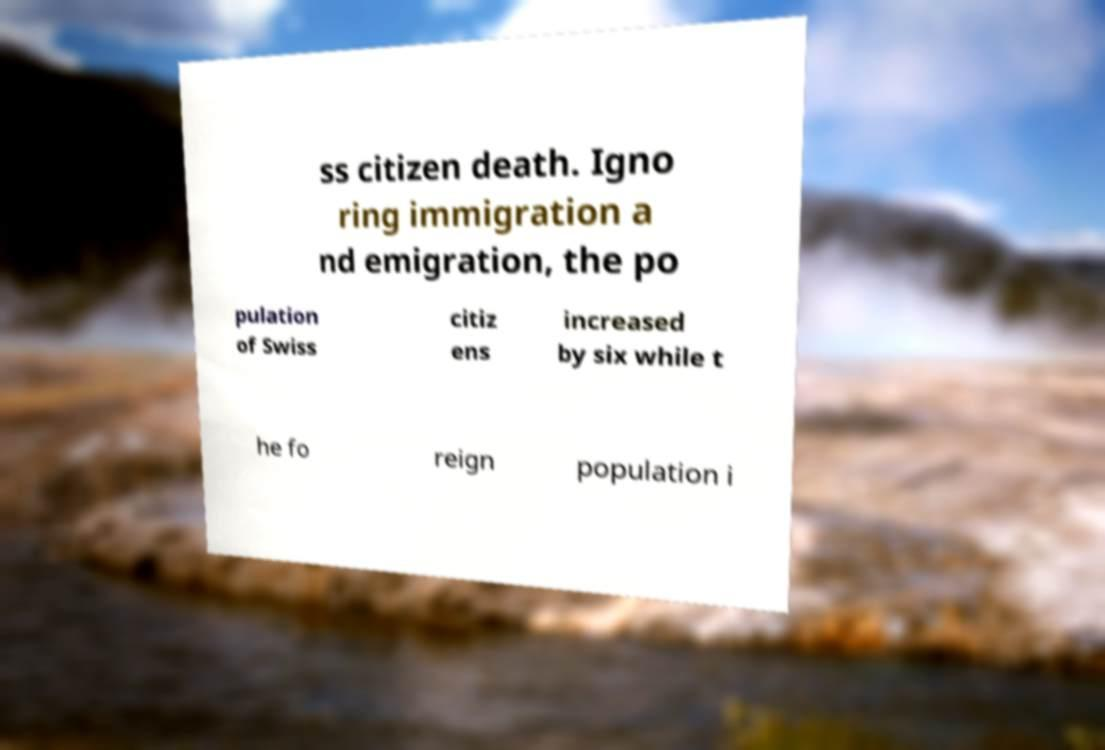Could you assist in decoding the text presented in this image and type it out clearly? ss citizen death. Igno ring immigration a nd emigration, the po pulation of Swiss citiz ens increased by six while t he fo reign population i 